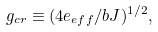Convert formula to latex. <formula><loc_0><loc_0><loc_500><loc_500>g _ { c r } \equiv ( 4 e _ { e f f } / b J ) ^ { 1 / 2 } ,</formula> 